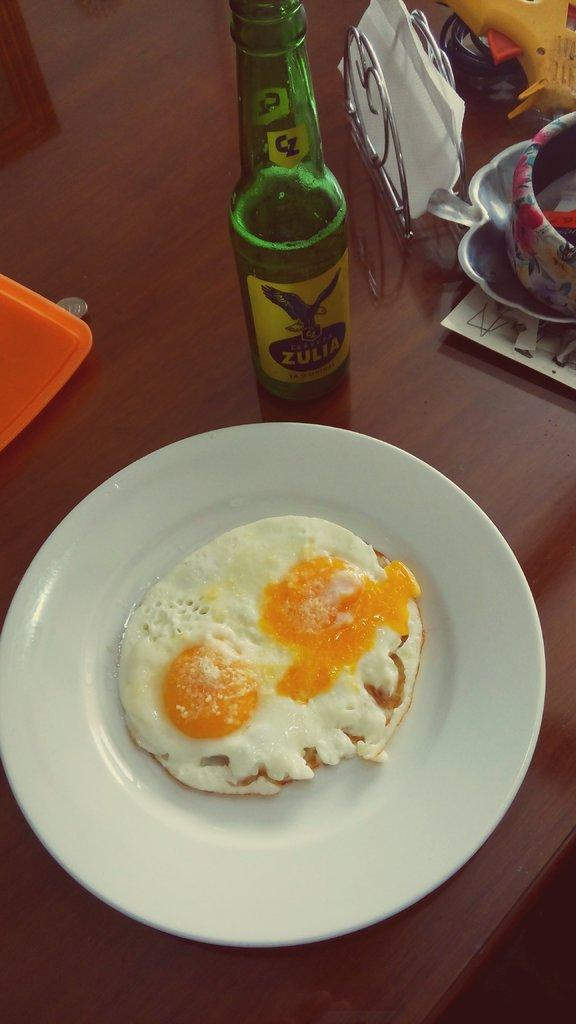What type of food is featured in the image? There is an egg omelet in the image. How is the egg omelet presented? The egg omelet is in a plate. What beverage-related item can be seen in the image? There is a wine bottle in the image. What can be used for cleaning or wiping in the image? There are tissues in the image. What type of surface are the objects placed on in the image? There are objects on a wooden table in the image. What type of furniture is visible in the image? There is no furniture visible in the image; only a wooden table is mentioned. What question is being asked in the image? There is no question being asked in the image; it is a still image of objects. 